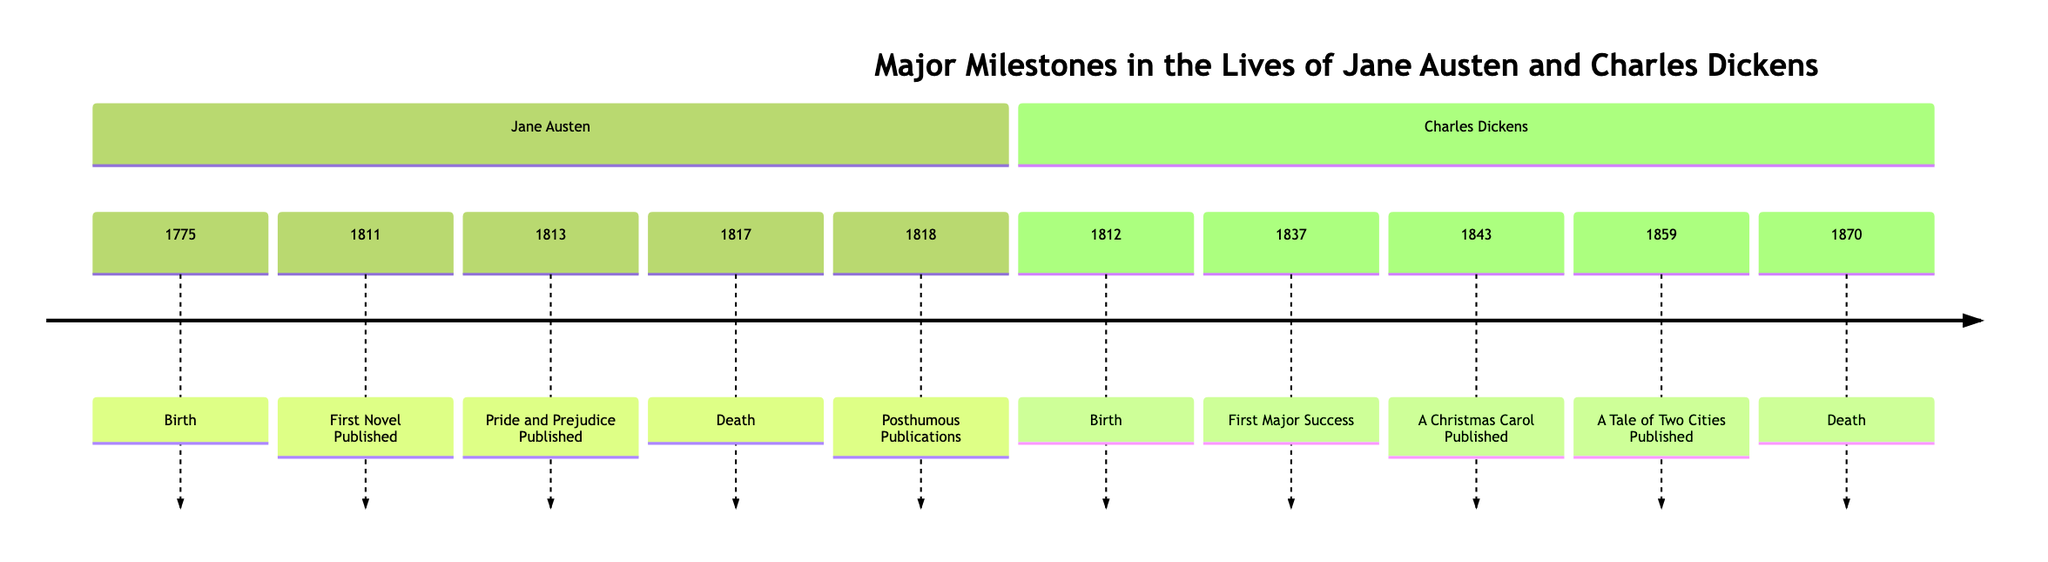What year was Jane Austen born? The diagram shows the year of Jane Austen's birth listed as 1775.
Answer: 1775 What event marks the first publication in Jane Austen's timeline? The first event listed for Jane Austen is "First Novel Published," which corresponds to the year 1811.
Answer: First Novel Published How many years did Jane Austen live? Jane Austen was born in 1775 and died in 1817. By subtracting these two years (1817 - 1775), we find that she lived for 42 years.
Answer: 42 What is the first major success of Charles Dickens? The diagram indicates that Charles Dickens' first major success was represented by "The Pickwick Papers," published in 1837.
Answer: The Pickwick Papers In which year was "A Christmas Carol" published? The timeline specifies that "A Christmas Carol" was published in 1843.
Answer: 1843 What were the years in which both authors published significant works? Jane Austen published her first novel in 1811, and Charles Dickens published his first major success in 1837. The years of significant works are 1811 for Austen and 1837 for Dickens.
Answer: 1811 and 1837 Who died first, Jane Austen or Charles Dickens? According to the timeline, Jane Austen died in 1817 and Charles Dickens died in 1870. Since 1817 comes before 1870, Jane Austen died first.
Answer: Jane Austen How many milestones are shown for Charles Dickens in the timeline? The diagram lists five milestones specifically for Charles Dickens, including birth, major works, and death.
Answer: 5 What is the last event listed in Jane Austen's timeline? The final entry in Jane Austen's section is "Posthumous Publications," which took place in 1818, following her death.
Answer: Posthumous Publications 